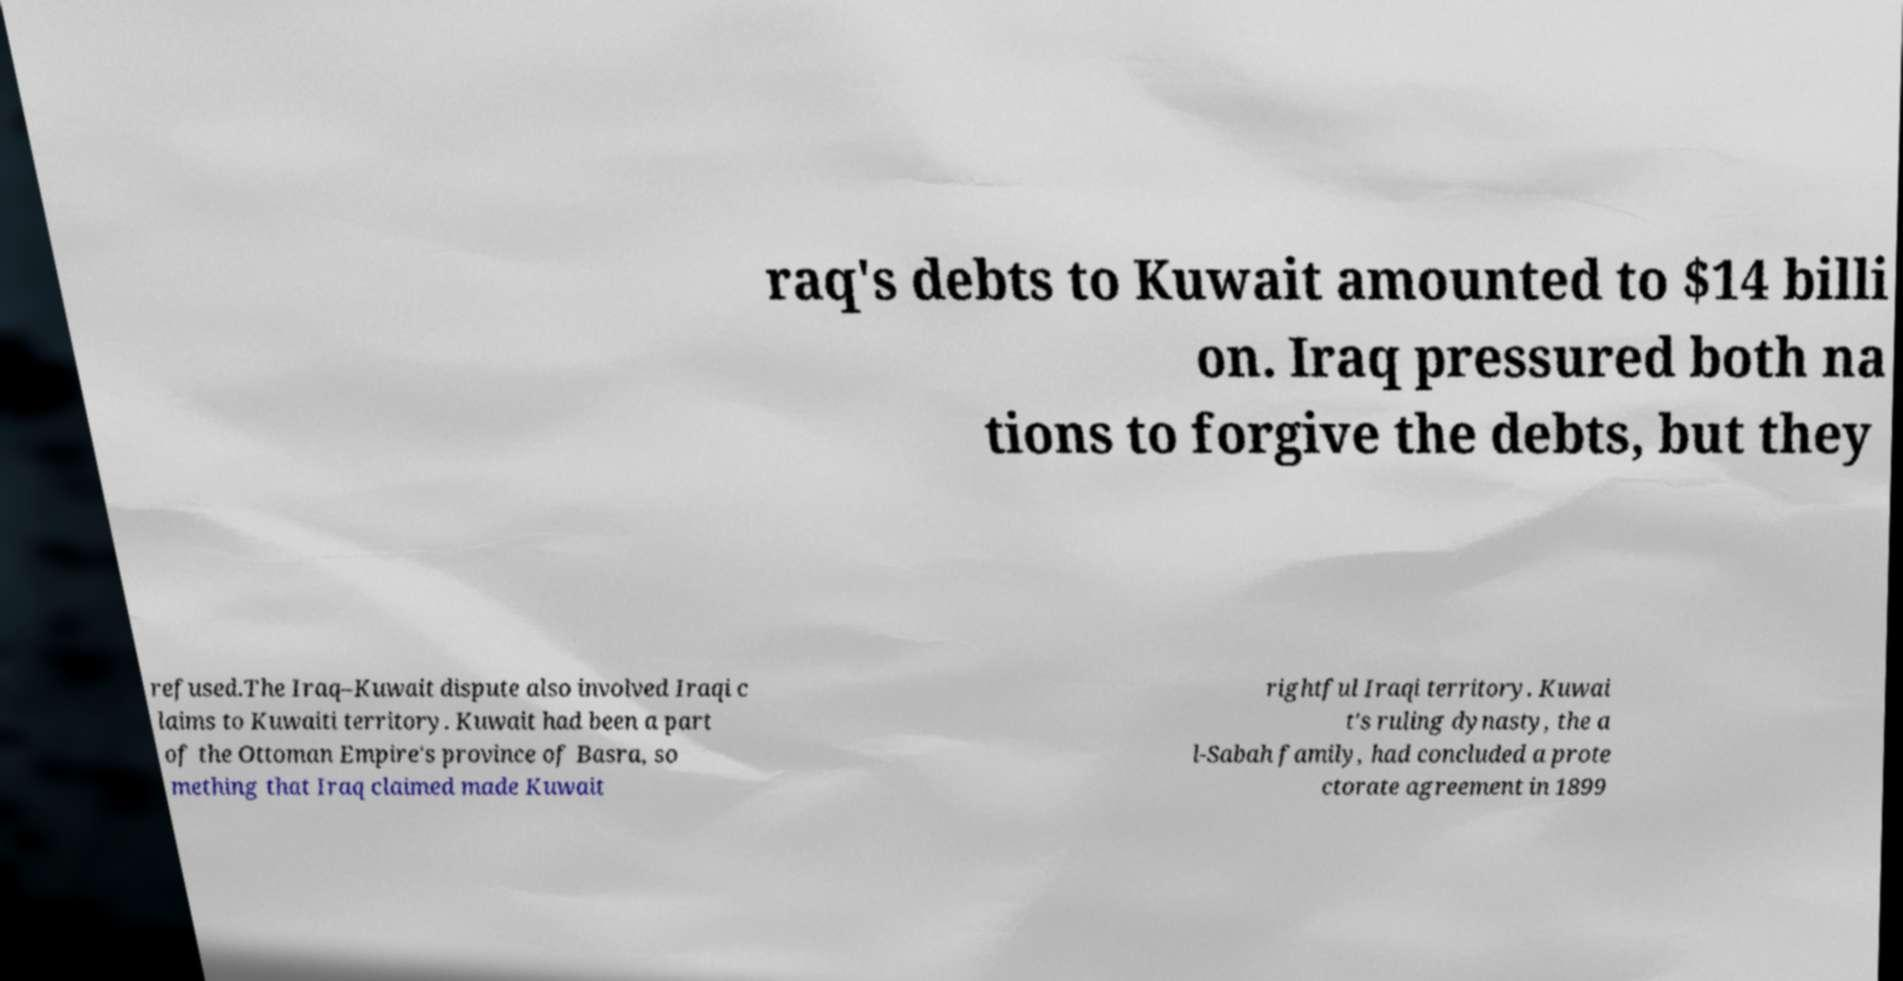I need the written content from this picture converted into text. Can you do that? raq's debts to Kuwait amounted to $14 billi on. Iraq pressured both na tions to forgive the debts, but they refused.The Iraq–Kuwait dispute also involved Iraqi c laims to Kuwaiti territory. Kuwait had been a part of the Ottoman Empire's province of Basra, so mething that Iraq claimed made Kuwait rightful Iraqi territory. Kuwai t's ruling dynasty, the a l-Sabah family, had concluded a prote ctorate agreement in 1899 